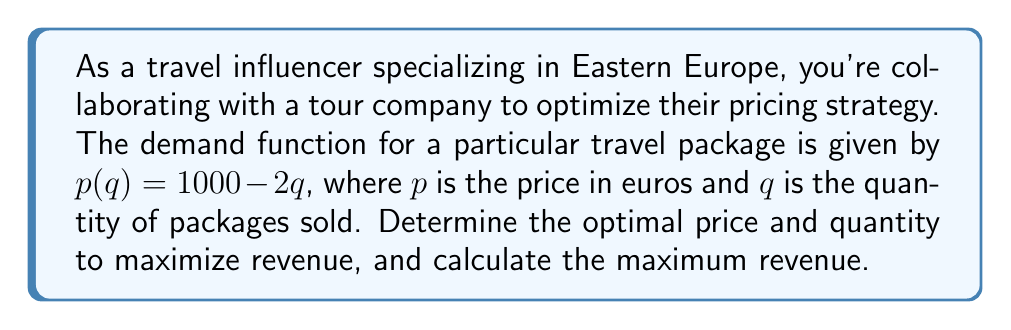Provide a solution to this math problem. To solve this problem, we'll follow these steps:

1) First, we need to find the revenue function. Revenue is price times quantity:
   $R(q) = p(q) \cdot q = (1000 - 2q) \cdot q = 1000q - 2q^2$

2) To find the marginal revenue function, we take the derivative of the revenue function:
   $MR(q) = R'(q) = 1000 - 4q$

3) The optimal quantity is where marginal revenue equals zero:
   $MR(q) = 0$
   $1000 - 4q = 0$
   $4q = 1000$
   $q = 250$

4) To find the optimal price, we substitute this quantity back into the demand function:
   $p(250) = 1000 - 2(250) = 1000 - 500 = 500$

5) The maximum revenue is calculated by plugging the optimal quantity into the revenue function:
   $R(250) = 1000(250) - 2(250)^2 = 250,000 - 125,000 = 125,000$

Therefore, the optimal strategy is to sell 250 packages at €500 each, which will generate a maximum revenue of €125,000.
Answer: Optimal price: €500; Optimal quantity: 250 packages; Maximum revenue: €125,000 